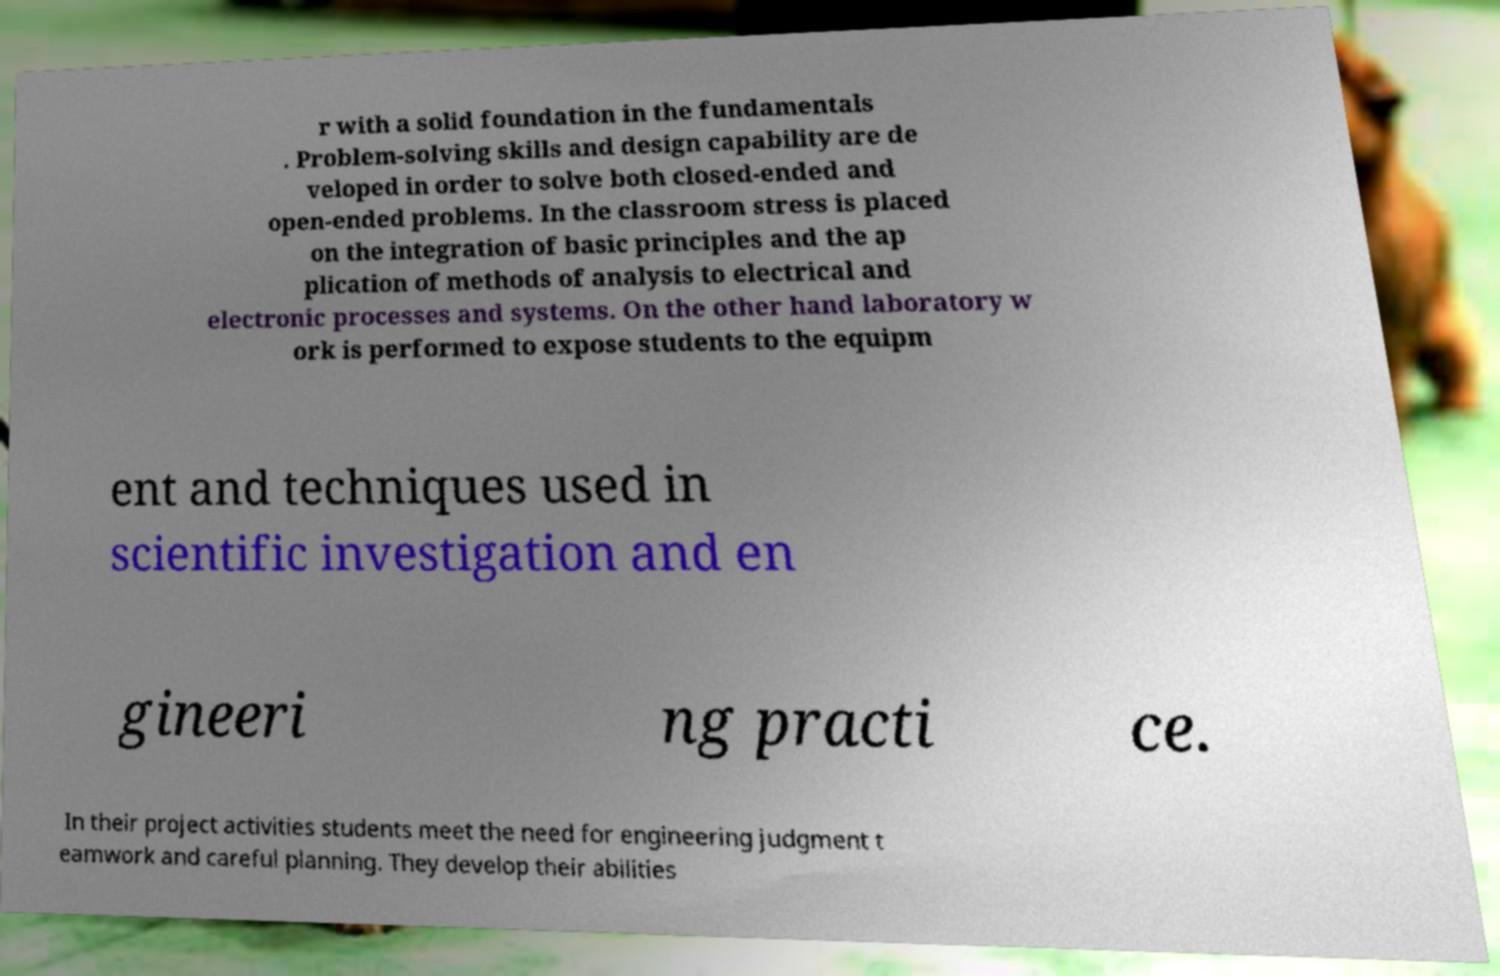I need the written content from this picture converted into text. Can you do that? r with a solid foundation in the fundamentals . Problem-solving skills and design capability are de veloped in order to solve both closed-ended and open-ended problems. In the classroom stress is placed on the integration of basic principles and the ap plication of methods of analysis to electrical and electronic processes and systems. On the other hand laboratory w ork is performed to expose students to the equipm ent and techniques used in scientific investigation and en gineeri ng practi ce. In their project activities students meet the need for engineering judgment t eamwork and careful planning. They develop their abilities 